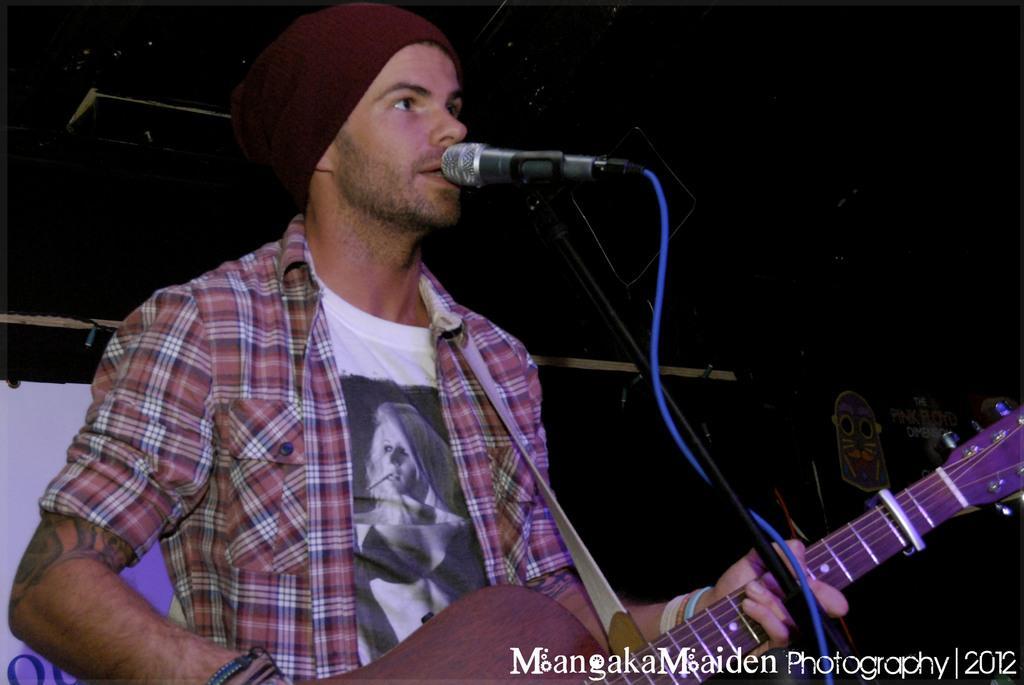Can you describe this image briefly? In this image we can see a person holding a guitar and playing it. This is the mic where he is singing through it. 